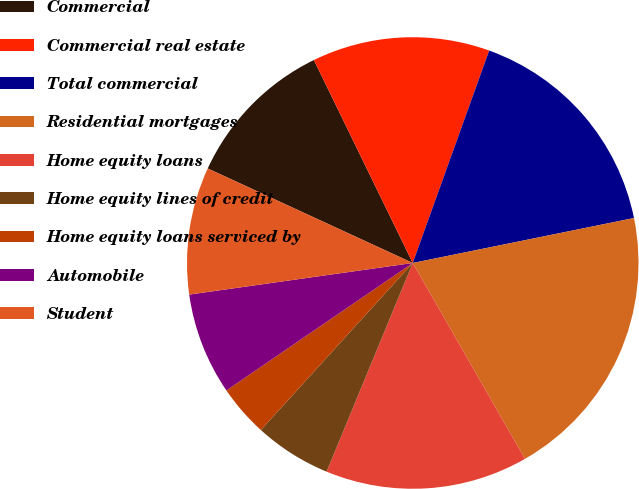<chart> <loc_0><loc_0><loc_500><loc_500><pie_chart><fcel>Commercial<fcel>Commercial real estate<fcel>Total commercial<fcel>Residential mortgages<fcel>Home equity loans<fcel>Home equity lines of credit<fcel>Home equity loans serviced by<fcel>Automobile<fcel>Student<nl><fcel>10.91%<fcel>12.71%<fcel>16.31%<fcel>19.91%<fcel>14.51%<fcel>5.51%<fcel>3.71%<fcel>7.31%<fcel>9.11%<nl></chart> 